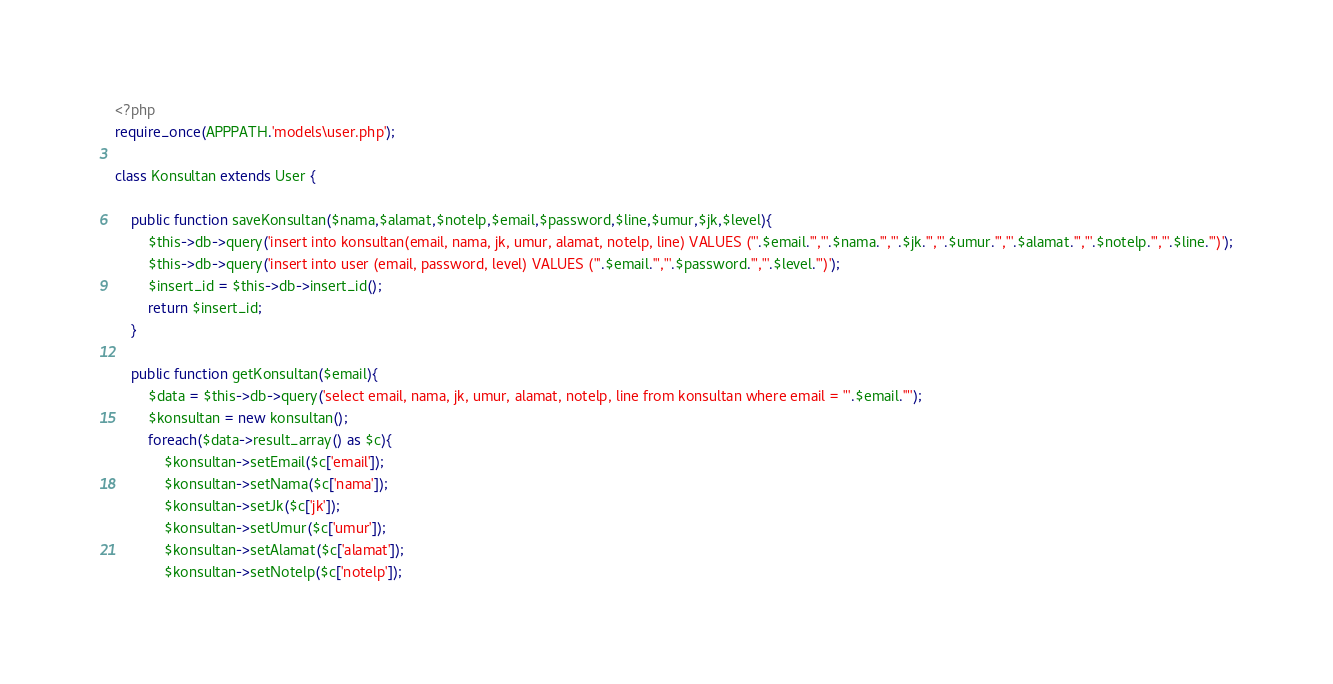Convert code to text. <code><loc_0><loc_0><loc_500><loc_500><_PHP_><?php
require_once(APPPATH.'models\user.php');

class Konsultan extends User {

	public function saveKonsultan($nama,$alamat,$notelp,$email,$password,$line,$umur,$jk,$level){
		$this->db->query('insert into konsultan(email, nama, jk, umur, alamat, notelp, line) VALUES ("'.$email.'","'.$nama.'","'.$jk.'","'.$umur.'","'.$alamat.'","'.$notelp.'","'.$line.'")');
		$this->db->query('insert into user (email, password, level) VALUES ("'.$email.'","'.$password.'","'.$level.'")');
		$insert_id = $this->db->insert_id();
		return $insert_id;
	}

	public function getKonsultan($email){
		$data = $this->db->query('select email, nama, jk, umur, alamat, notelp, line from konsultan where email = "'.$email.'"');
		$konsultan = new konsultan();
		foreach($data->result_array() as $c){
			$konsultan->setEmail($c['email']);
			$konsultan->setNama($c['nama']);
			$konsultan->setJk($c['jk']);
			$konsultan->setUmur($c['umur']);
			$konsultan->setAlamat($c['alamat']);
			$konsultan->setNotelp($c['notelp']);</code> 